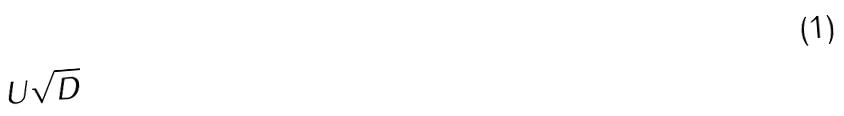Convert formula to latex. <formula><loc_0><loc_0><loc_500><loc_500>U \sqrt { D }</formula> 